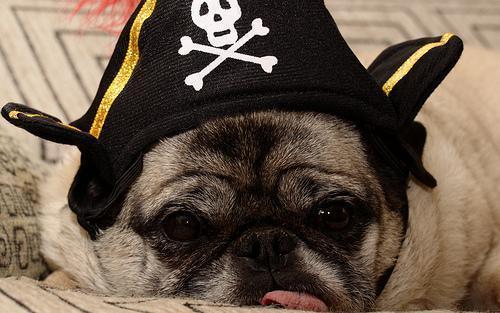How many eyes are open?
Give a very brief answer. 2. 